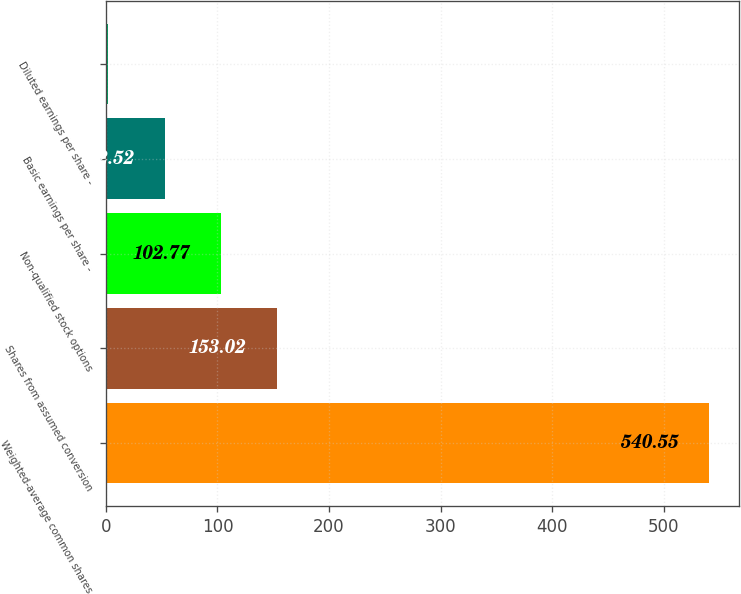Convert chart. <chart><loc_0><loc_0><loc_500><loc_500><bar_chart><fcel>Weighted-average common shares<fcel>Shares from assumed conversion<fcel>Non-qualified stock options<fcel>Basic earnings per share -<fcel>Diluted earnings per share -<nl><fcel>540.55<fcel>153.02<fcel>102.77<fcel>52.52<fcel>2.27<nl></chart> 